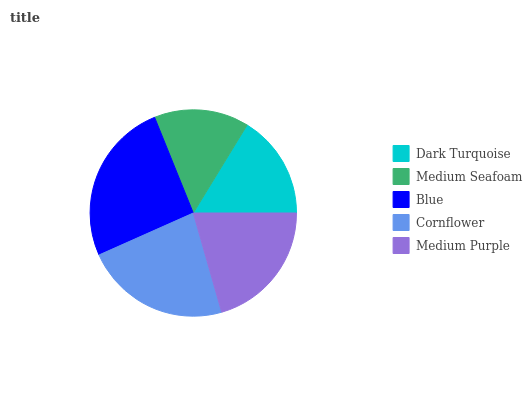Is Medium Seafoam the minimum?
Answer yes or no. Yes. Is Blue the maximum?
Answer yes or no. Yes. Is Blue the minimum?
Answer yes or no. No. Is Medium Seafoam the maximum?
Answer yes or no. No. Is Blue greater than Medium Seafoam?
Answer yes or no. Yes. Is Medium Seafoam less than Blue?
Answer yes or no. Yes. Is Medium Seafoam greater than Blue?
Answer yes or no. No. Is Blue less than Medium Seafoam?
Answer yes or no. No. Is Medium Purple the high median?
Answer yes or no. Yes. Is Medium Purple the low median?
Answer yes or no. Yes. Is Blue the high median?
Answer yes or no. No. Is Dark Turquoise the low median?
Answer yes or no. No. 